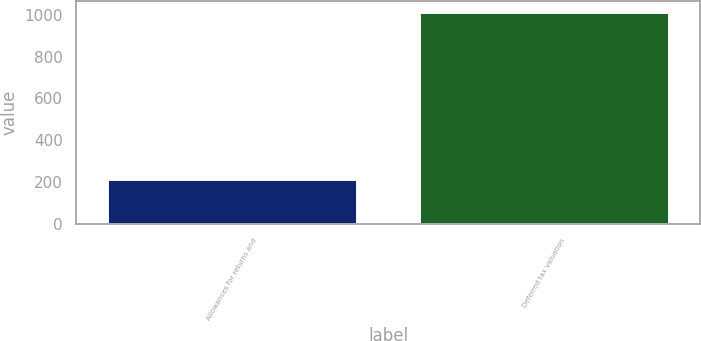Convert chart to OTSL. <chart><loc_0><loc_0><loc_500><loc_500><bar_chart><fcel>Allowances for returns and<fcel>Deferred tax valuation<nl><fcel>213<fcel>1014<nl></chart> 